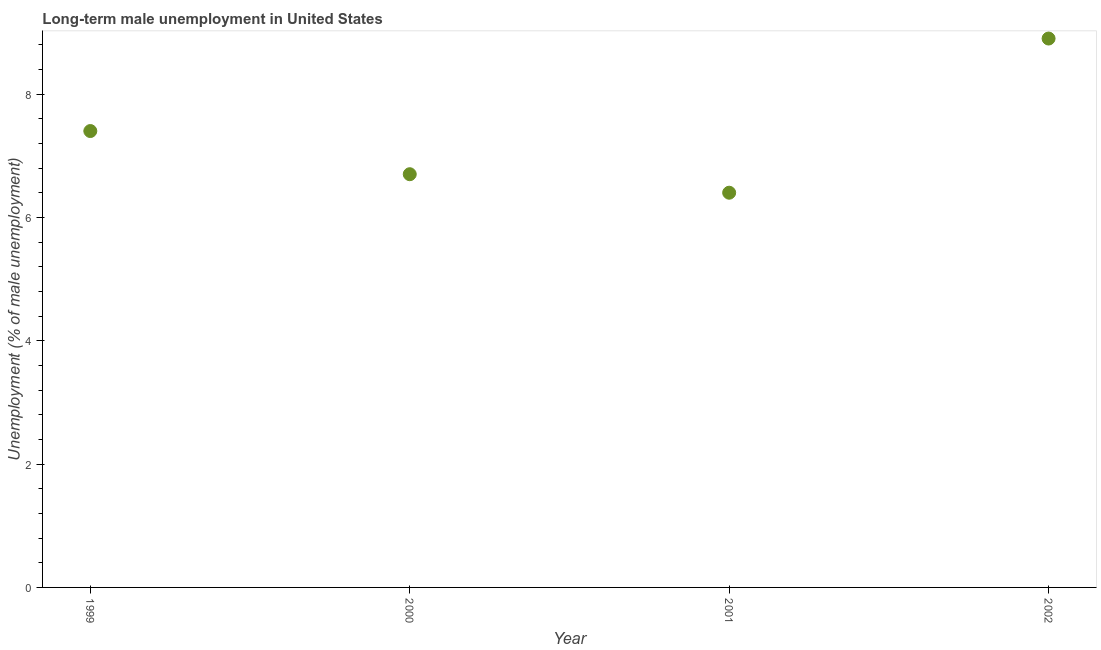What is the long-term male unemployment in 1999?
Your response must be concise. 7.4. Across all years, what is the maximum long-term male unemployment?
Give a very brief answer. 8.9. Across all years, what is the minimum long-term male unemployment?
Ensure brevity in your answer.  6.4. In which year was the long-term male unemployment maximum?
Offer a very short reply. 2002. What is the sum of the long-term male unemployment?
Keep it short and to the point. 29.4. What is the difference between the long-term male unemployment in 1999 and 2001?
Ensure brevity in your answer.  1. What is the average long-term male unemployment per year?
Keep it short and to the point. 7.35. What is the median long-term male unemployment?
Keep it short and to the point. 7.05. In how many years, is the long-term male unemployment greater than 3.6 %?
Make the answer very short. 4. Do a majority of the years between 2000 and 2002 (inclusive) have long-term male unemployment greater than 2 %?
Make the answer very short. Yes. What is the ratio of the long-term male unemployment in 2000 to that in 2002?
Ensure brevity in your answer.  0.75. Is the difference between the long-term male unemployment in 1999 and 2002 greater than the difference between any two years?
Your answer should be very brief. No. What is the difference between the highest and the second highest long-term male unemployment?
Provide a short and direct response. 1.5. What is the difference between the highest and the lowest long-term male unemployment?
Offer a terse response. 2.5. How many dotlines are there?
Make the answer very short. 1. Are the values on the major ticks of Y-axis written in scientific E-notation?
Your answer should be very brief. No. Does the graph contain any zero values?
Your response must be concise. No. What is the title of the graph?
Your answer should be very brief. Long-term male unemployment in United States. What is the label or title of the X-axis?
Make the answer very short. Year. What is the label or title of the Y-axis?
Provide a succinct answer. Unemployment (% of male unemployment). What is the Unemployment (% of male unemployment) in 1999?
Make the answer very short. 7.4. What is the Unemployment (% of male unemployment) in 2000?
Your response must be concise. 6.7. What is the Unemployment (% of male unemployment) in 2001?
Keep it short and to the point. 6.4. What is the Unemployment (% of male unemployment) in 2002?
Your response must be concise. 8.9. What is the difference between the Unemployment (% of male unemployment) in 1999 and 2000?
Offer a very short reply. 0.7. What is the difference between the Unemployment (% of male unemployment) in 2000 and 2001?
Keep it short and to the point. 0.3. What is the difference between the Unemployment (% of male unemployment) in 2000 and 2002?
Give a very brief answer. -2.2. What is the difference between the Unemployment (% of male unemployment) in 2001 and 2002?
Offer a very short reply. -2.5. What is the ratio of the Unemployment (% of male unemployment) in 1999 to that in 2000?
Provide a short and direct response. 1.1. What is the ratio of the Unemployment (% of male unemployment) in 1999 to that in 2001?
Make the answer very short. 1.16. What is the ratio of the Unemployment (% of male unemployment) in 1999 to that in 2002?
Give a very brief answer. 0.83. What is the ratio of the Unemployment (% of male unemployment) in 2000 to that in 2001?
Provide a short and direct response. 1.05. What is the ratio of the Unemployment (% of male unemployment) in 2000 to that in 2002?
Offer a very short reply. 0.75. What is the ratio of the Unemployment (% of male unemployment) in 2001 to that in 2002?
Give a very brief answer. 0.72. 